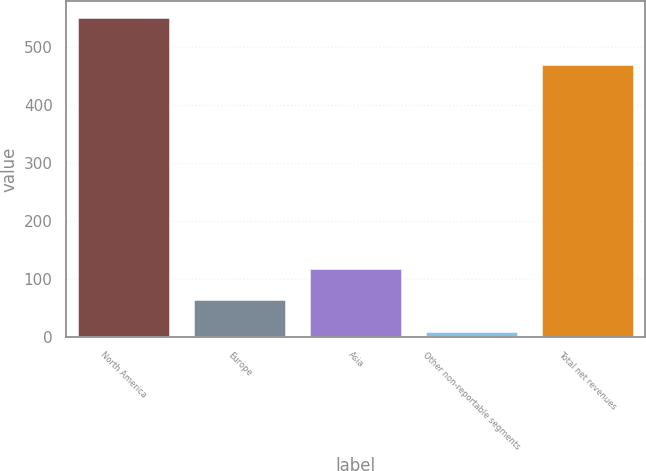Convert chart to OTSL. <chart><loc_0><loc_0><loc_500><loc_500><bar_chart><fcel>North America<fcel>Europe<fcel>Asia<fcel>Other non-reportable segments<fcel>Total net revenues<nl><fcel>552<fcel>65.37<fcel>119.44<fcel>11.3<fcel>470.5<nl></chart> 